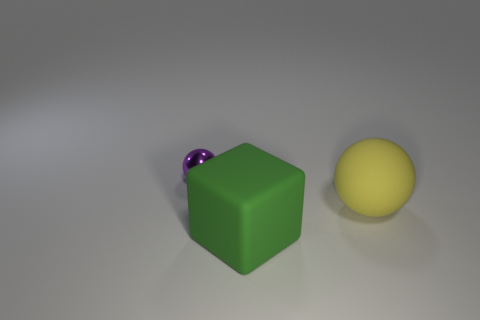Are there any small purple cubes made of the same material as the green object?
Provide a succinct answer. No. Is the small sphere the same color as the big matte ball?
Make the answer very short. No. What is the material of the object that is behind the cube and right of the small purple metallic ball?
Ensure brevity in your answer.  Rubber. What color is the large rubber ball?
Offer a terse response. Yellow. What number of other metal things are the same shape as the large yellow object?
Offer a very short reply. 1. Are the object that is on the left side of the big matte block and the object right of the green matte object made of the same material?
Your answer should be very brief. No. What size is the yellow matte thing that is behind the rubber thing in front of the big sphere?
Your response must be concise. Large. Is there any other thing that has the same size as the rubber cube?
Offer a terse response. Yes. What material is the purple object that is the same shape as the big yellow matte thing?
Give a very brief answer. Metal. Is the shape of the big matte thing that is in front of the large ball the same as the object behind the yellow object?
Ensure brevity in your answer.  No. 